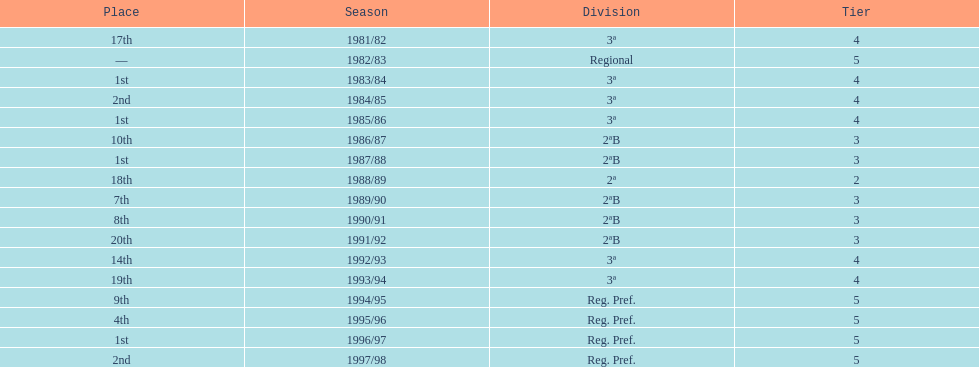How many seasons are shown in this chart? 17. 